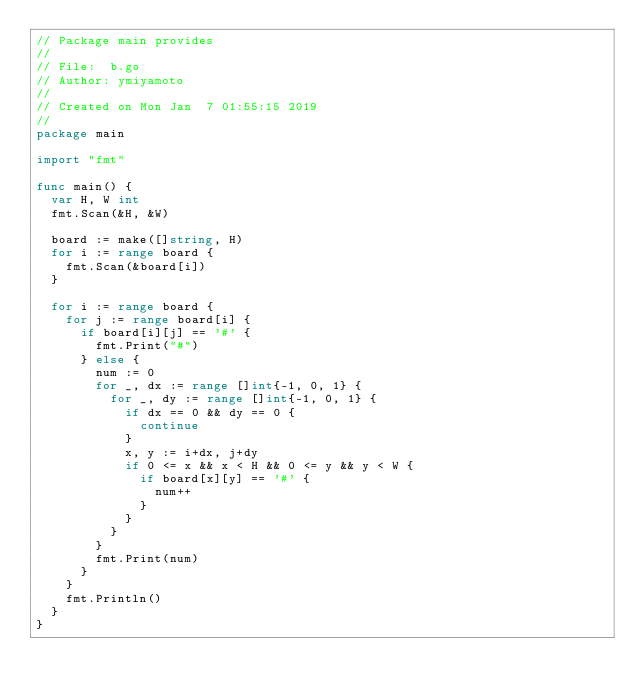Convert code to text. <code><loc_0><loc_0><loc_500><loc_500><_Go_>// Package main provides
//
// File:  b.go
// Author: ymiyamoto
//
// Created on Mon Jan  7 01:55:15 2019
//
package main

import "fmt"

func main() {
	var H, W int
	fmt.Scan(&H, &W)

	board := make([]string, H)
	for i := range board {
		fmt.Scan(&board[i])
	}

	for i := range board {
		for j := range board[i] {
			if board[i][j] == '#' {
				fmt.Print("#")
			} else {
				num := 0
				for _, dx := range []int{-1, 0, 1} {
					for _, dy := range []int{-1, 0, 1} {
						if dx == 0 && dy == 0 {
							continue
						}
						x, y := i+dx, j+dy
						if 0 <= x && x < H && 0 <= y && y < W {
							if board[x][y] == '#' {
								num++
							}
						}
					}
				}
				fmt.Print(num)
			}
		}
		fmt.Println()
	}
}
</code> 